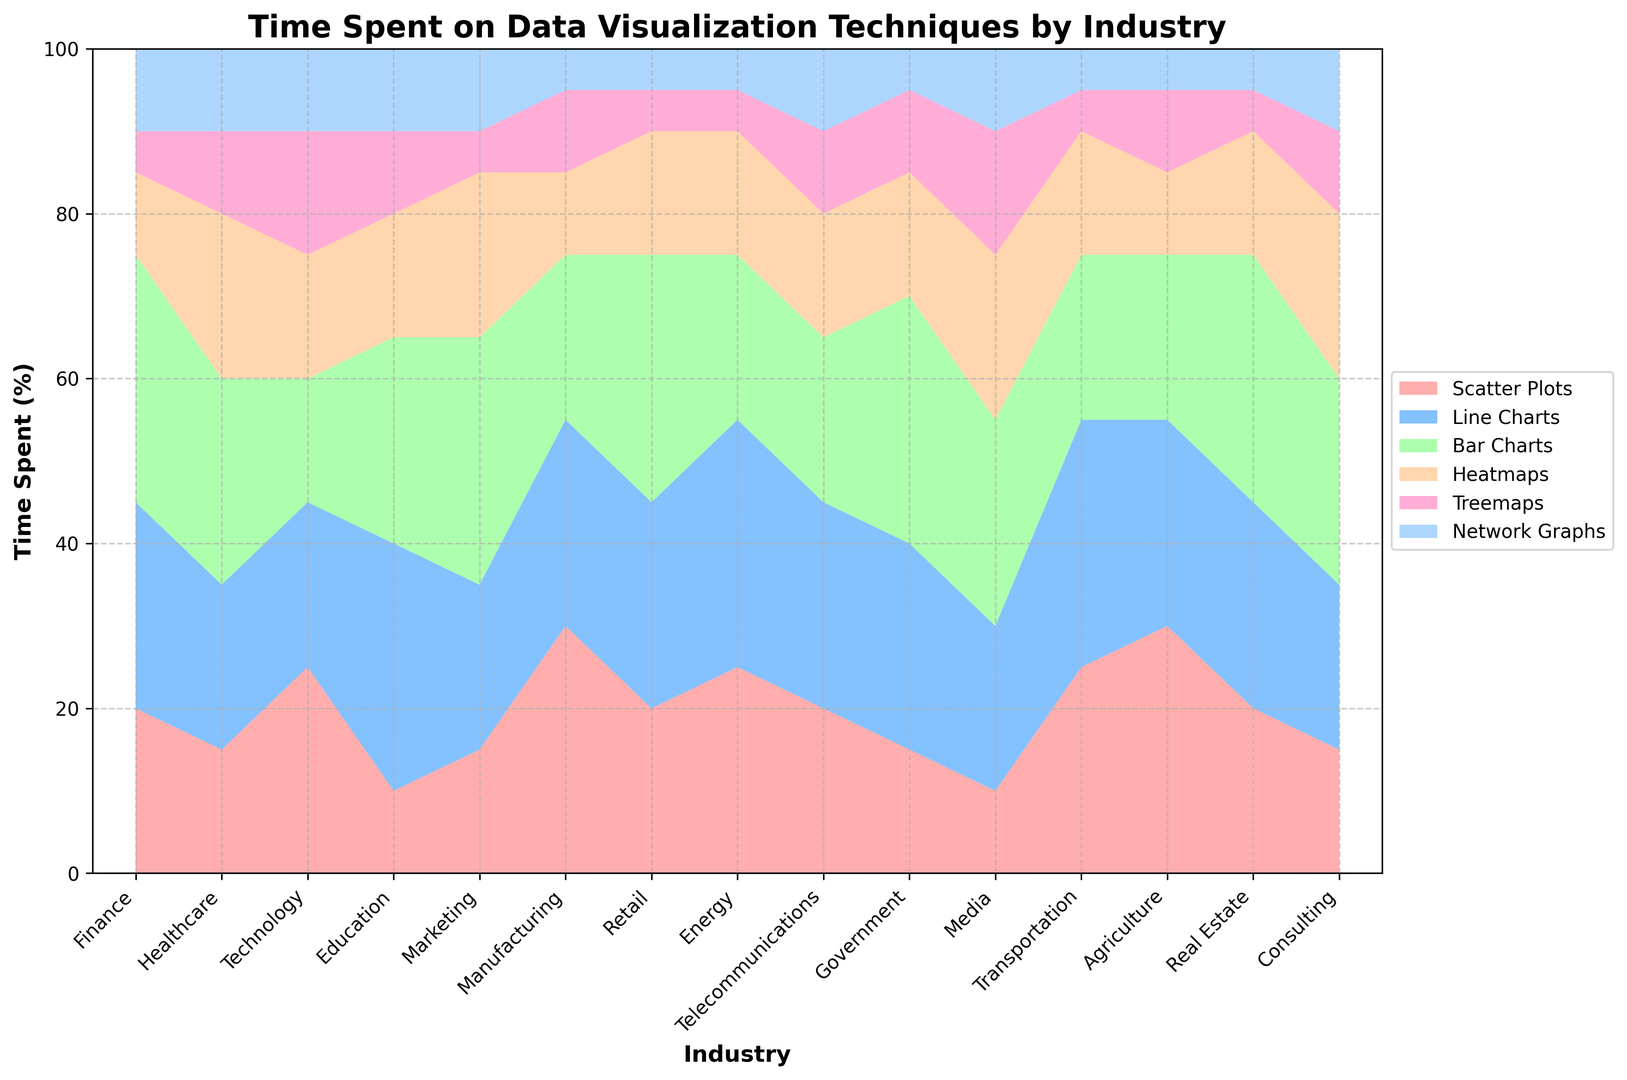What industry spends the most time on Bar Charts? To find the industry that spends the most time on Bar Charts, look for the segment with the highest value in the Bar Charts category. Finance, Retail, Government, and Real Estate all spend 30% of their time on Bar Charts, which is the highest share.
Answer: Finance, Retail, Government, Real Estate How much total time does the Technology industry spend on Scatter Plots and Network Graphs combined? Add the percentages of time spent on Scatter Plots (25%) and Network Graphs (10%) in the Technology industry. 25 + 10 = 35
Answer: 35% Which industry spends equal time on Heatmaps and Network Graphs? Look for the industry where the values for both Heatmaps and Network Graphs are the same. In Healthcare, both Heatmaps and Network Graphs are at 10%.
Answer: Healthcare Which two industries spend the most time on Scatter Plots? Identify the highest values in Scatter Plots, and check their corresponding industries. Manufacturing and Agriculture each spend 30% on Scatter Plots, the most among all industries.
Answer: Manufacturing, Agriculture In the Finance industry, how much more time is spent on Line Charts than on Treemaps? Subtract the percentage of time spent on Treemaps from the percentage of time spent on Line Charts in Finance. 25 - 5 = 20
Answer: 20% What is the average time spent on Line Charts by Education, Energy, and Transportation industries? Add the percentages of time spent on Line Charts by Education (30%), Energy (30%), and Transportation (30%) and divide by 3. (30 + 30 + 30) / 3 = 30
Answer: 30% Which industry spends the least overall time on Network Graphs? Look for the lowest value in the Network Graphs category and identify the corresponding industry. Both Manufacturing, Retail, Energy, Transportation, Agriculture, and Government spend 5%, which is the lowest.
Answer: Manufacturing, Retail, Energy, Transportation, Agriculture, Government How much total time does the Media industry spend on Treemaps and Heatmaps combined, compared to the Technology industry? Add the percentages of time spent by the Media industry on Treemaps (15%) and Heatmaps (20%) and compare it with the same sums from the Technology industry (15% Treemaps + 15% Heatmaps). Both sums result in 35%. So, Media = Technology = 35%
Answer: 35% Which industry spends more time on Bar Charts than Scatter Plots but less time on Line Charts than Line Charts? Look for industries where Bar Charts value is higher than Scatter Plots and less than Line Charts. Finance, Marketing, Retail, Government, and Real Estate meet these criteria.
Answer: Finance, Marketing, Retail, Government, Real Estate 